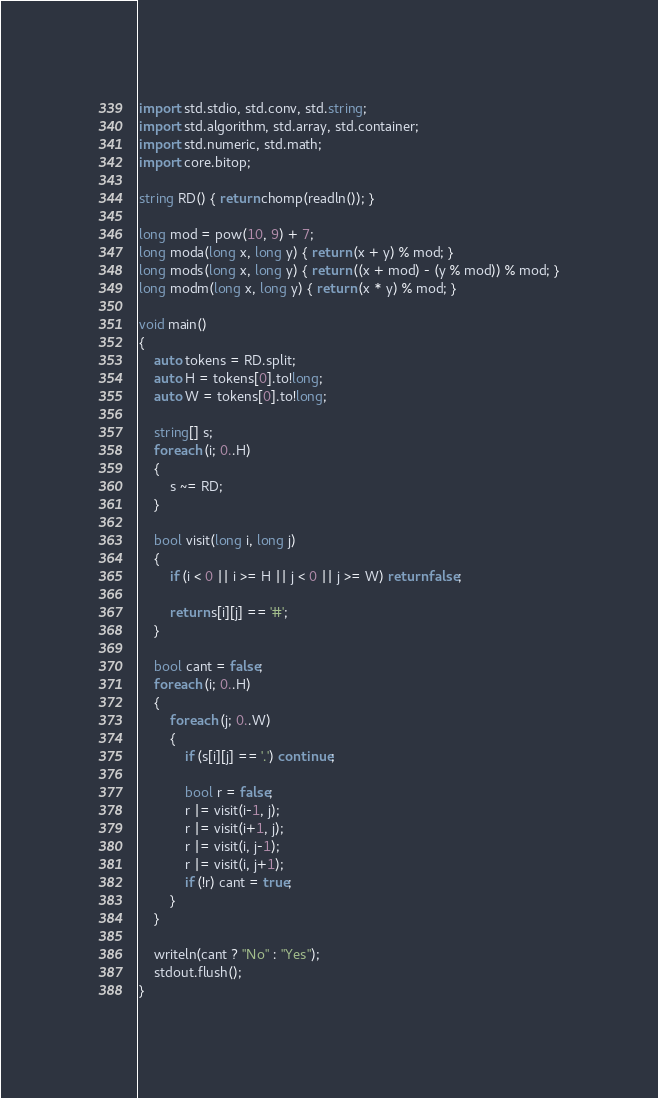Convert code to text. <code><loc_0><loc_0><loc_500><loc_500><_D_>import std.stdio, std.conv, std.string;
import std.algorithm, std.array, std.container;
import std.numeric, std.math;
import core.bitop;

string RD() { return chomp(readln()); }

long mod = pow(10, 9) + 7;
long moda(long x, long y) { return (x + y) % mod; }
long mods(long x, long y) { return ((x + mod) - (y % mod)) % mod; }
long modm(long x, long y) { return (x * y) % mod; }

void main()
{
	auto tokens = RD.split;
	auto H = tokens[0].to!long;
	auto W = tokens[0].to!long;
	
	string[] s;
	foreach (i; 0..H)
	{
		s ~= RD;
	}

	bool visit(long i, long j)
	{
		if (i < 0 || i >= H || j < 0 || j >= W) return false;

		return s[i][j] == '#';
	}

	bool cant = false;
	foreach (i; 0..H)
	{
		foreach (j; 0..W)
		{
			if (s[i][j] == '.') continue;

			bool r = false;
			r |= visit(i-1, j);
			r |= visit(i+1, j);
			r |= visit(i, j-1);
			r |= visit(i, j+1);
			if (!r) cant = true;
		}
	}

	writeln(cant ? "No" : "Yes");
	stdout.flush();
}</code> 